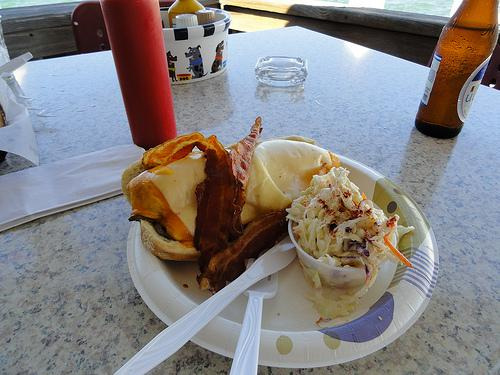Question: where is the plate?
Choices:
A. On the counter.
B. On the table.
C. In the sink.
D. In the waiters hand.
Answer with the letter. Answer: B Question: what is on the plate?
Choices:
A. Apples.
B. A fork.
C. A napkin.
D. Food.
Answer with the letter. Answer: D 